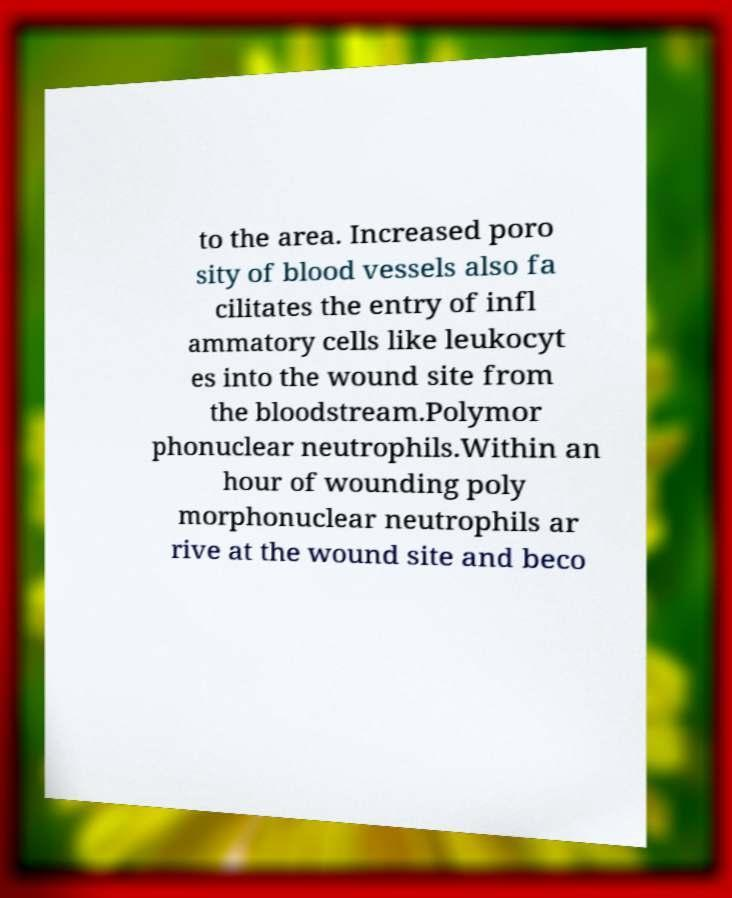Can you accurately transcribe the text from the provided image for me? to the area. Increased poro sity of blood vessels also fa cilitates the entry of infl ammatory cells like leukocyt es into the wound site from the bloodstream.Polymor phonuclear neutrophils.Within an hour of wounding poly morphonuclear neutrophils ar rive at the wound site and beco 